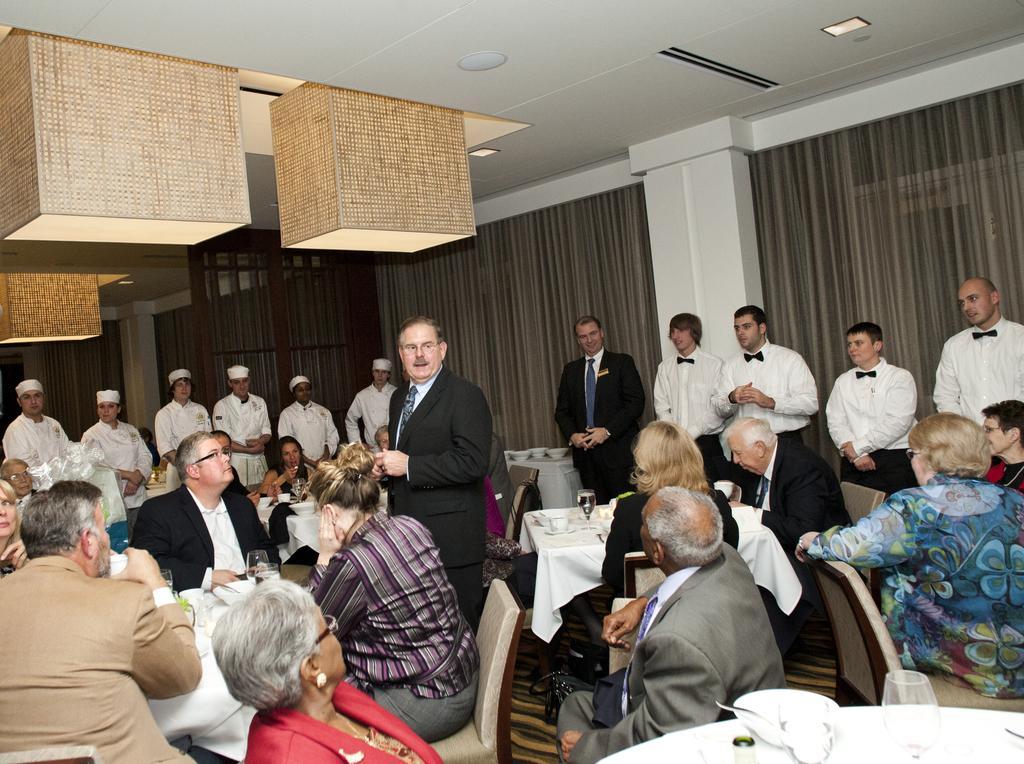Can you describe this image briefly? In this image, we can see a group of people sitting on the chair in front of the table. On the table, we can see some glasses. In the right corner, we can also see a table. On the table, we can also see white colored cloth, bowl with spoon and a glass. In the background, we can see a group of people standing. In the middle of the image, we can see a table, on the table, we can see white colored cloth, two bowls and a glass with some drink. In the background, we can see curtains, wall. At the top, we can see a roof with few lights. 